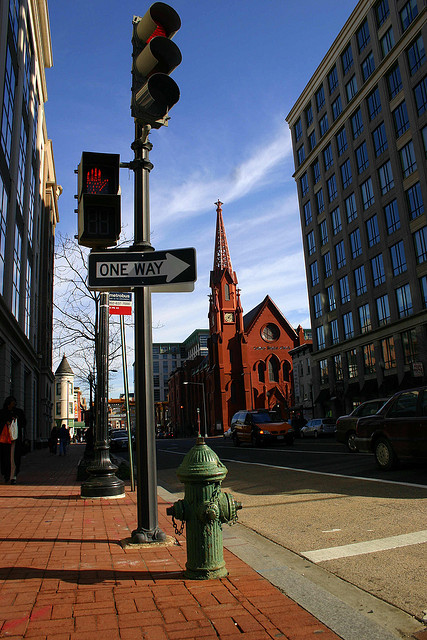How many giraffes are there? There are no giraffes in the image. The image features an urban scene with a traffic light, a one-way street sign, buildings, and a red church in the background. 